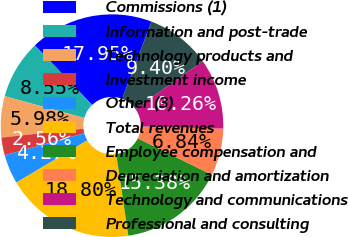Convert chart to OTSL. <chart><loc_0><loc_0><loc_500><loc_500><pie_chart><fcel>Commissions (1)<fcel>Information and post-trade<fcel>Technology products and<fcel>Investment income<fcel>Other (3)<fcel>Total revenues<fcel>Employee compensation and<fcel>Depreciation and amortization<fcel>Technology and communications<fcel>Professional and consulting<nl><fcel>17.95%<fcel>8.55%<fcel>5.98%<fcel>2.56%<fcel>4.27%<fcel>18.8%<fcel>15.38%<fcel>6.84%<fcel>10.26%<fcel>9.4%<nl></chart> 